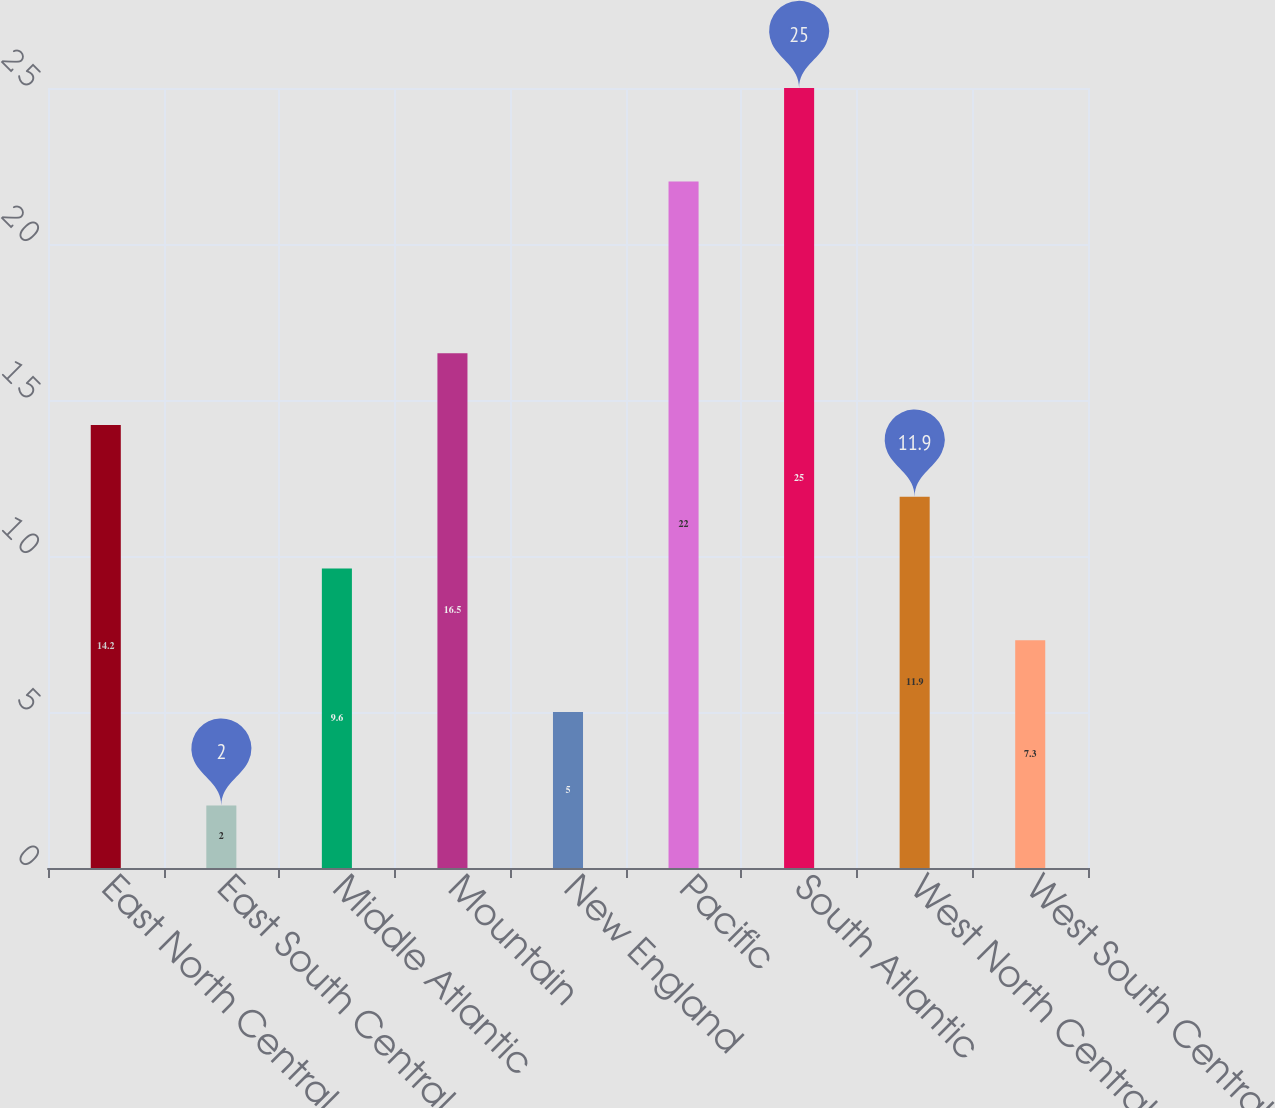Convert chart to OTSL. <chart><loc_0><loc_0><loc_500><loc_500><bar_chart><fcel>East North Central<fcel>East South Central<fcel>Middle Atlantic<fcel>Mountain<fcel>New England<fcel>Pacific<fcel>South Atlantic<fcel>West North Central<fcel>West South Central<nl><fcel>14.2<fcel>2<fcel>9.6<fcel>16.5<fcel>5<fcel>22<fcel>25<fcel>11.9<fcel>7.3<nl></chart> 